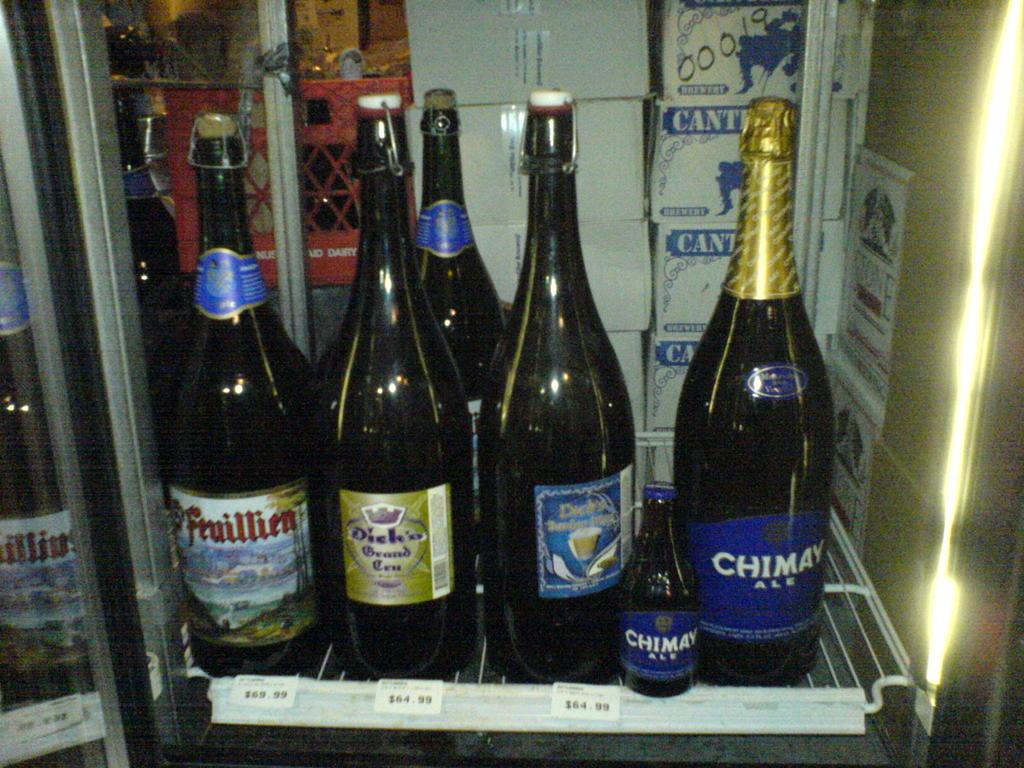What is the name of the bottle to the very right?
Provide a succinct answer. Chimay. 